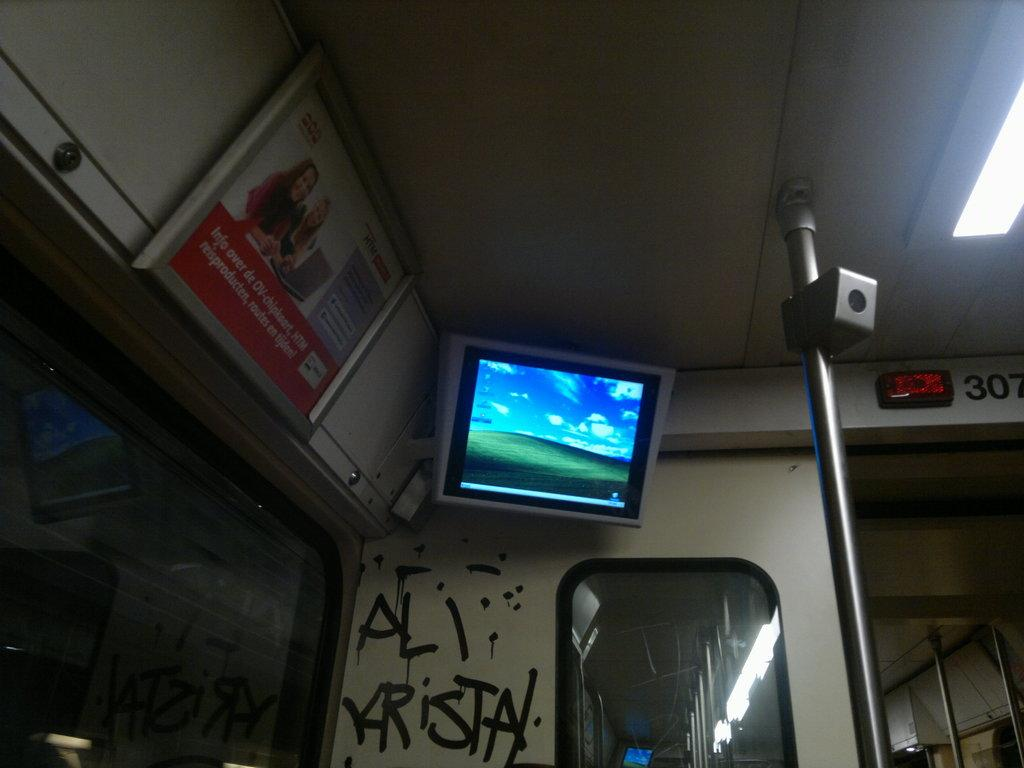<image>
Render a clear and concise summary of the photo. An ad from HTM is next to a TV in a train. 